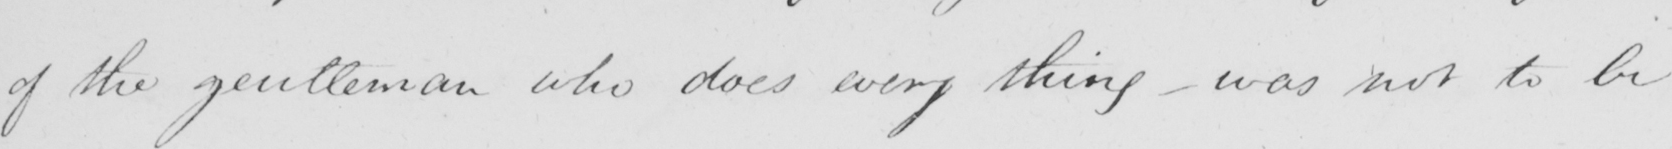Please transcribe the handwritten text in this image. of the gentleman who does every thing  _  was not to be 